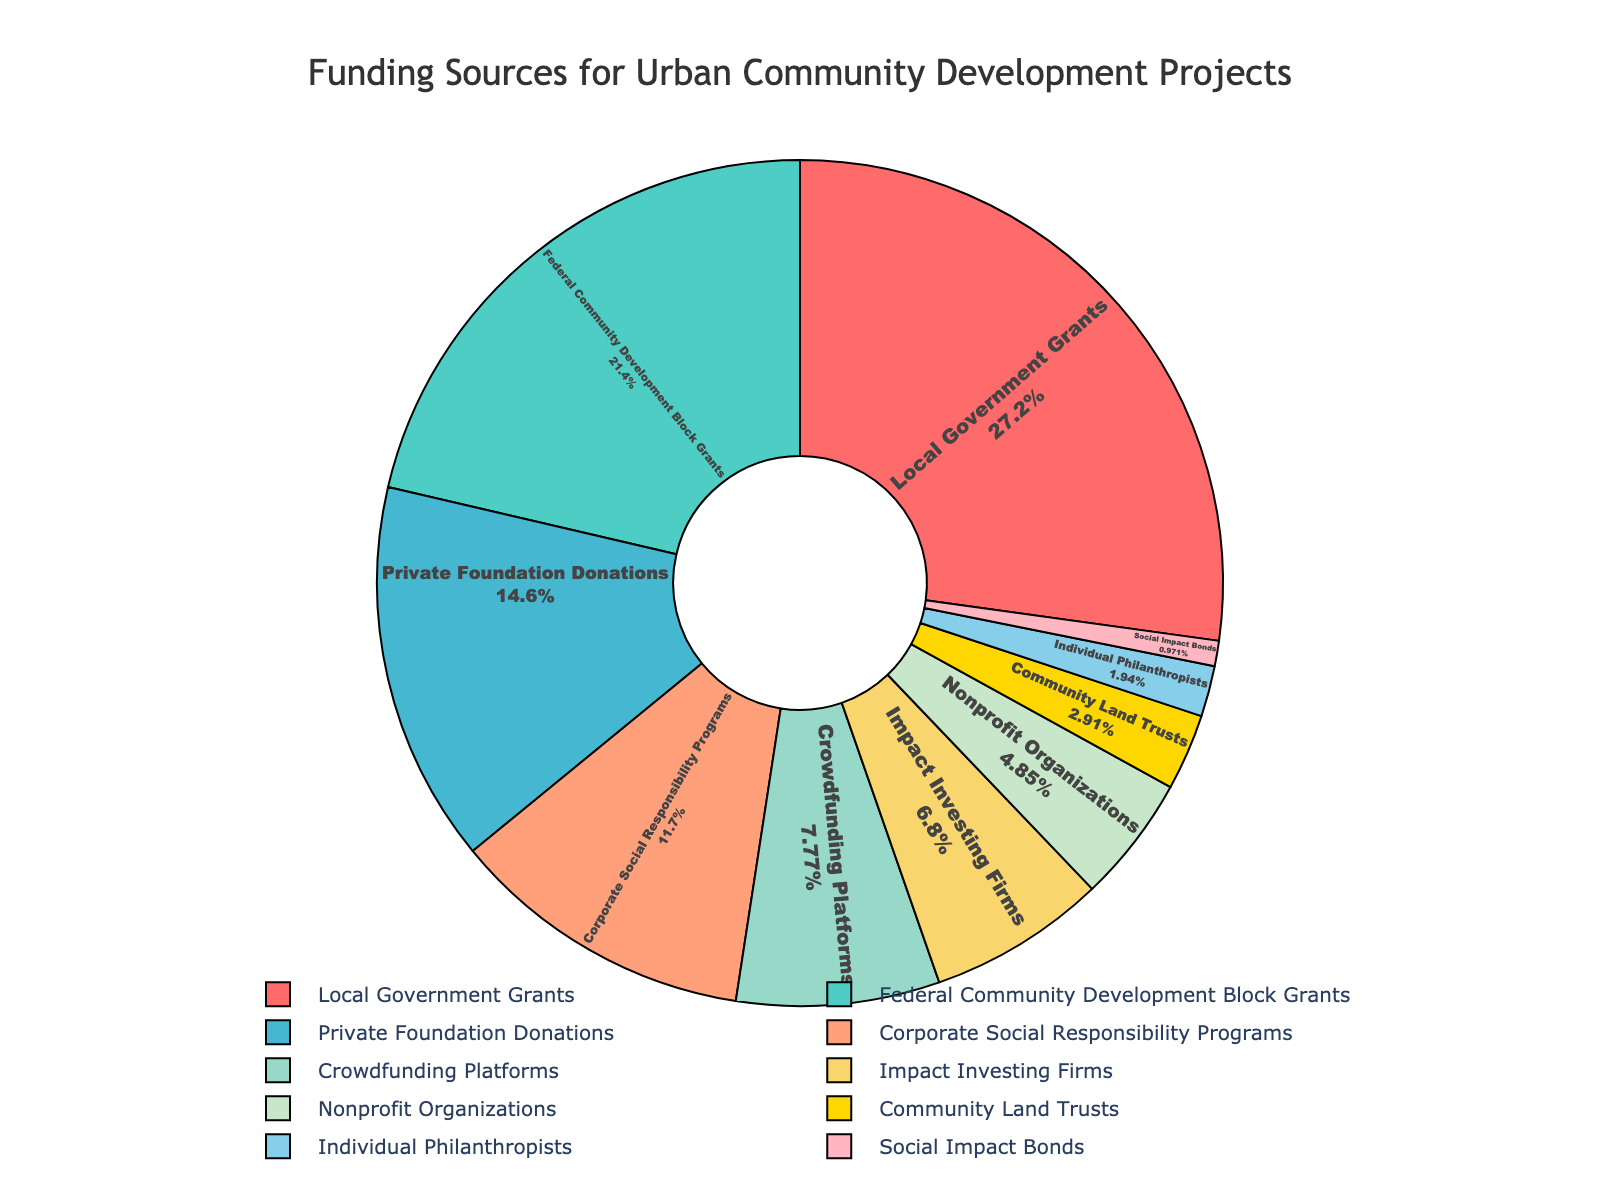Which funding source contributes the highest percentage to community development projects? The segment with the largest share is labeled "Local Government Grants," representing 28%. By checking the labels and corresponding percentages, this source is the highest.
Answer: Local Government Grants What is the sum of the percentages from Crowdfunding Platforms and Impact Investing Firms? Crowdfunding Platforms contribute 8% and Impact Investing Firms contribute 7%. Adding these percentages together gives 8% + 7% = 15%.
Answer: 15% Which funding source contributes the smallest percentage? The smallest segment is labeled "Social Impact Bonds," and its percentage is 1%. By checking the percentages, Social Impact Bonds contribute the least.
Answer: Social Impact Bonds How much more does Federal Community Development Block Grants contribute than Corporate Social Responsibility Programs? Federal Community Development Block Grants contribute 22% and Corporate Social Responsibility Programs contribute 12%. The difference is 22% - 12% = 10%.
Answer: 10% If we combine Private Foundation Donations and Nonprofit Organizations, what is their total contribution percentage? Private Foundation Donations make up 15% and Nonprofit Organizations 5%. Adding these together gives 15% + 5% = 20%.
Answer: 20% What is the average percentage contribution of Community Land Trusts, Individual Philanthropists, and Social Impact Bonds? The contributions are 3%, 2%, and 1% respectively. The sum is 3% + 2% + 1% = 6%, and there are 3 sources. The average is 6% / 3 = 2%.
Answer: 2% Which funding source is represented in red on the pie chart? The segment colored red, as per the description, is labeled "Local Government Grants," and it has the highest percentage of 28%.
Answer: Local Government Grants Are there more funding sources contributing less than or equal to 5%, or greater than 5%? Counting the segments with ≤ 5%: Nonprofit Organizations (5%), Community Land Trusts (3%), Individual Philanthropists (2%), Social Impact Bonds (1%), gives 4 sources. Segments with > 5% are 6 sources. Therefore, there are more sources contributing > 5%.
Answer: Greater than 5% 